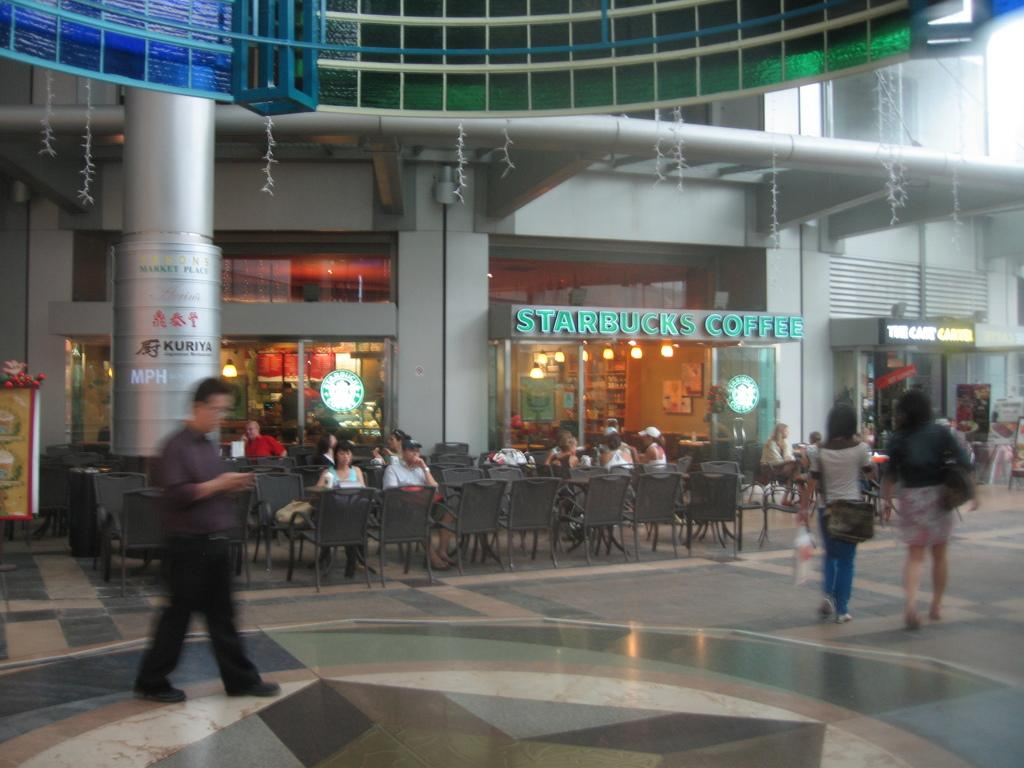Where was the image taken? The image was taken outside a building. What are the people in the image doing? There are people walking and sitting on chairs in the image. What can be seen in the background of the image? There are shops in the background of the image. What type of respect can be seen being shown to the carpenter in the image? There is no carpenter present in the image, so it is not possible to determine if any respect is being shown. 